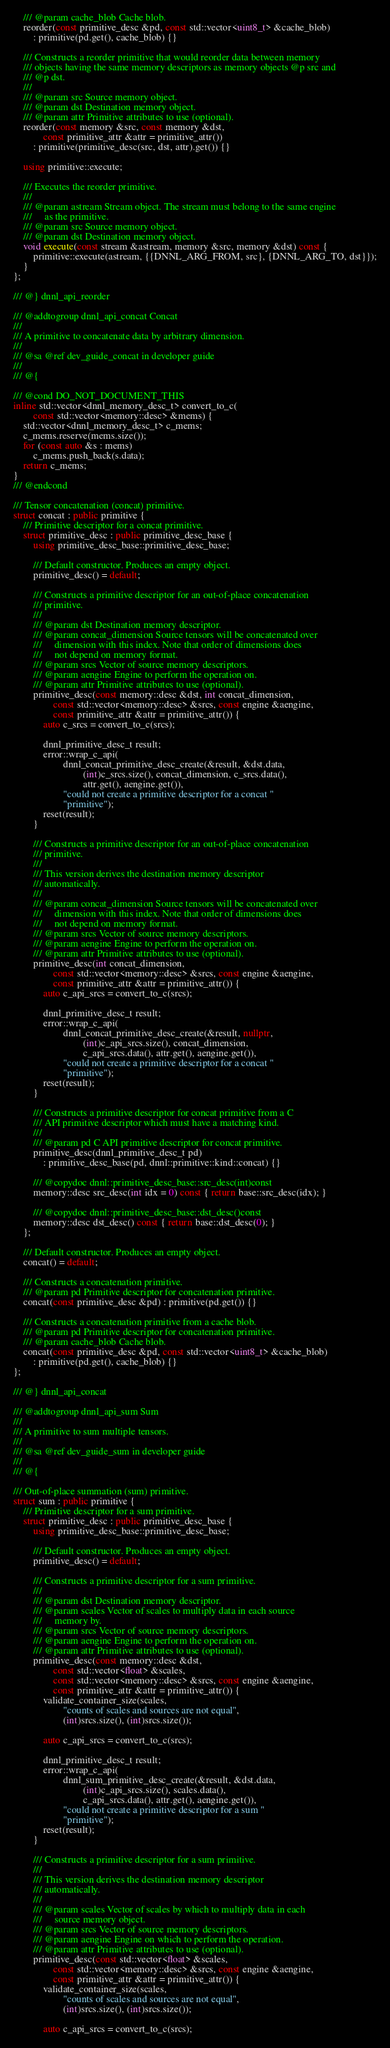<code> <loc_0><loc_0><loc_500><loc_500><_C++_>    /// @param cache_blob Cache blob.
    reorder(const primitive_desc &pd, const std::vector<uint8_t> &cache_blob)
        : primitive(pd.get(), cache_blob) {}

    /// Constructs a reorder primitive that would reorder data between memory
    /// objects having the same memory descriptors as memory objects @p src and
    /// @p dst.
    ///
    /// @param src Source memory object.
    /// @param dst Destination memory object.
    /// @param attr Primitive attributes to use (optional).
    reorder(const memory &src, const memory &dst,
            const primitive_attr &attr = primitive_attr())
        : primitive(primitive_desc(src, dst, attr).get()) {}

    using primitive::execute;

    /// Executes the reorder primitive.
    ///
    /// @param astream Stream object. The stream must belong to the same engine
    ///     as the primitive.
    /// @param src Source memory object.
    /// @param dst Destination memory object.
    void execute(const stream &astream, memory &src, memory &dst) const {
        primitive::execute(astream, {{DNNL_ARG_FROM, src}, {DNNL_ARG_TO, dst}});
    }
};

/// @} dnnl_api_reorder

/// @addtogroup dnnl_api_concat Concat
///
/// A primitive to concatenate data by arbitrary dimension.
///
/// @sa @ref dev_guide_concat in developer guide
///
/// @{

/// @cond DO_NOT_DOCUMENT_THIS
inline std::vector<dnnl_memory_desc_t> convert_to_c(
        const std::vector<memory::desc> &mems) {
    std::vector<dnnl_memory_desc_t> c_mems;
    c_mems.reserve(mems.size());
    for (const auto &s : mems)
        c_mems.push_back(s.data);
    return c_mems;
}
/// @endcond

/// Tensor concatenation (concat) primitive.
struct concat : public primitive {
    /// Primitive descriptor for a concat primitive.
    struct primitive_desc : public primitive_desc_base {
        using primitive_desc_base::primitive_desc_base;

        /// Default constructor. Produces an empty object.
        primitive_desc() = default;

        /// Constructs a primitive descriptor for an out-of-place concatenation
        /// primitive.
        ///
        /// @param dst Destination memory descriptor.
        /// @param concat_dimension Source tensors will be concatenated over
        ///     dimension with this index. Note that order of dimensions does
        ///     not depend on memory format.
        /// @param srcs Vector of source memory descriptors.
        /// @param aengine Engine to perform the operation on.
        /// @param attr Primitive attributes to use (optional).
        primitive_desc(const memory::desc &dst, int concat_dimension,
                const std::vector<memory::desc> &srcs, const engine &aengine,
                const primitive_attr &attr = primitive_attr()) {
            auto c_srcs = convert_to_c(srcs);

            dnnl_primitive_desc_t result;
            error::wrap_c_api(
                    dnnl_concat_primitive_desc_create(&result, &dst.data,
                            (int)c_srcs.size(), concat_dimension, c_srcs.data(),
                            attr.get(), aengine.get()),
                    "could not create a primitive descriptor for a concat "
                    "primitive");
            reset(result);
        }

        /// Constructs a primitive descriptor for an out-of-place concatenation
        /// primitive.
        ///
        /// This version derives the destination memory descriptor
        /// automatically.
        ///
        /// @param concat_dimension Source tensors will be concatenated over
        ///     dimension with this index. Note that order of dimensions does
        ///     not depend on memory format.
        /// @param srcs Vector of source memory descriptors.
        /// @param aengine Engine to perform the operation on.
        /// @param attr Primitive attributes to use (optional).
        primitive_desc(int concat_dimension,
                const std::vector<memory::desc> &srcs, const engine &aengine,
                const primitive_attr &attr = primitive_attr()) {
            auto c_api_srcs = convert_to_c(srcs);

            dnnl_primitive_desc_t result;
            error::wrap_c_api(
                    dnnl_concat_primitive_desc_create(&result, nullptr,
                            (int)c_api_srcs.size(), concat_dimension,
                            c_api_srcs.data(), attr.get(), aengine.get()),
                    "could not create a primitive descriptor for a concat "
                    "primitive");
            reset(result);
        }

        /// Constructs a primitive descriptor for concat primitive from a C
        /// API primitive descriptor which must have a matching kind.
        ///
        /// @param pd C API primitive descriptor for concat primitive.
        primitive_desc(dnnl_primitive_desc_t pd)
            : primitive_desc_base(pd, dnnl::primitive::kind::concat) {}

        /// @copydoc dnnl::primitive_desc_base::src_desc(int)const
        memory::desc src_desc(int idx = 0) const { return base::src_desc(idx); }

        /// @copydoc dnnl::primitive_desc_base::dst_desc()const
        memory::desc dst_desc() const { return base::dst_desc(0); }
    };

    /// Default constructor. Produces an empty object.
    concat() = default;

    /// Constructs a concatenation primitive.
    /// @param pd Primitive descriptor for concatenation primitive.
    concat(const primitive_desc &pd) : primitive(pd.get()) {}

    /// Constructs a concatenation primitive from a cache blob.
    /// @param pd Primitive descriptor for concatenation primitive.
    /// @param cache_blob Cache blob.
    concat(const primitive_desc &pd, const std::vector<uint8_t> &cache_blob)
        : primitive(pd.get(), cache_blob) {}
};

/// @} dnnl_api_concat

/// @addtogroup dnnl_api_sum Sum
///
/// A primitive to sum multiple tensors.
///
/// @sa @ref dev_guide_sum in developer guide
///
/// @{

/// Out-of-place summation (sum) primitive.
struct sum : public primitive {
    /// Primitive descriptor for a sum primitive.
    struct primitive_desc : public primitive_desc_base {
        using primitive_desc_base::primitive_desc_base;

        /// Default constructor. Produces an empty object.
        primitive_desc() = default;

        /// Constructs a primitive descriptor for a sum primitive.
        ///
        /// @param dst Destination memory descriptor.
        /// @param scales Vector of scales to multiply data in each source
        ///     memory by.
        /// @param srcs Vector of source memory descriptors.
        /// @param aengine Engine to perform the operation on.
        /// @param attr Primitive attributes to use (optional).
        primitive_desc(const memory::desc &dst,
                const std::vector<float> &scales,
                const std::vector<memory::desc> &srcs, const engine &aengine,
                const primitive_attr &attr = primitive_attr()) {
            validate_container_size(scales,
                    "counts of scales and sources are not equal",
                    (int)srcs.size(), (int)srcs.size());

            auto c_api_srcs = convert_to_c(srcs);

            dnnl_primitive_desc_t result;
            error::wrap_c_api(
                    dnnl_sum_primitive_desc_create(&result, &dst.data,
                            (int)c_api_srcs.size(), scales.data(),
                            c_api_srcs.data(), attr.get(), aengine.get()),
                    "could not create a primitive descriptor for a sum "
                    "primitive");
            reset(result);
        }

        /// Constructs a primitive descriptor for a sum primitive.
        ///
        /// This version derives the destination memory descriptor
        /// automatically.
        ///
        /// @param scales Vector of scales by which to multiply data in each
        ///     source memory object.
        /// @param srcs Vector of source memory descriptors.
        /// @param aengine Engine on which to perform the operation.
        /// @param attr Primitive attributes to use (optional).
        primitive_desc(const std::vector<float> &scales,
                const std::vector<memory::desc> &srcs, const engine &aengine,
                const primitive_attr &attr = primitive_attr()) {
            validate_container_size(scales,
                    "counts of scales and sources are not equal",
                    (int)srcs.size(), (int)srcs.size());

            auto c_api_srcs = convert_to_c(srcs);</code> 